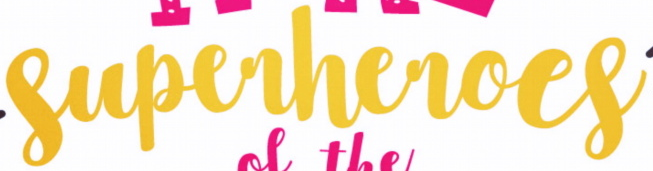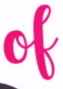What words can you see in these images in sequence, separated by a semicolon? superheroes; of 